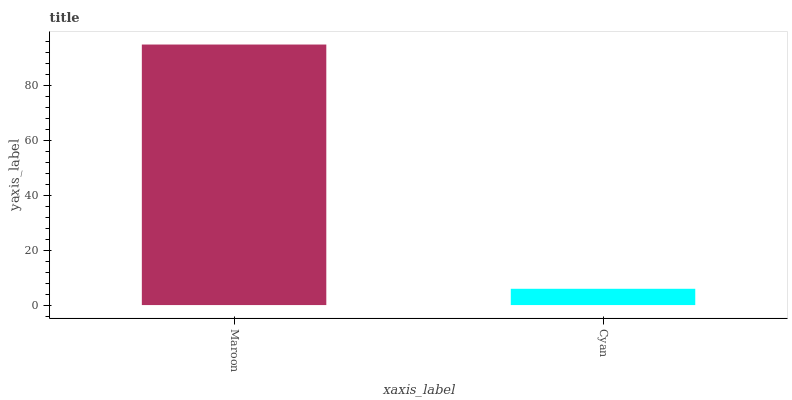Is Cyan the minimum?
Answer yes or no. Yes. Is Maroon the maximum?
Answer yes or no. Yes. Is Cyan the maximum?
Answer yes or no. No. Is Maroon greater than Cyan?
Answer yes or no. Yes. Is Cyan less than Maroon?
Answer yes or no. Yes. Is Cyan greater than Maroon?
Answer yes or no. No. Is Maroon less than Cyan?
Answer yes or no. No. Is Maroon the high median?
Answer yes or no. Yes. Is Cyan the low median?
Answer yes or no. Yes. Is Cyan the high median?
Answer yes or no. No. Is Maroon the low median?
Answer yes or no. No. 